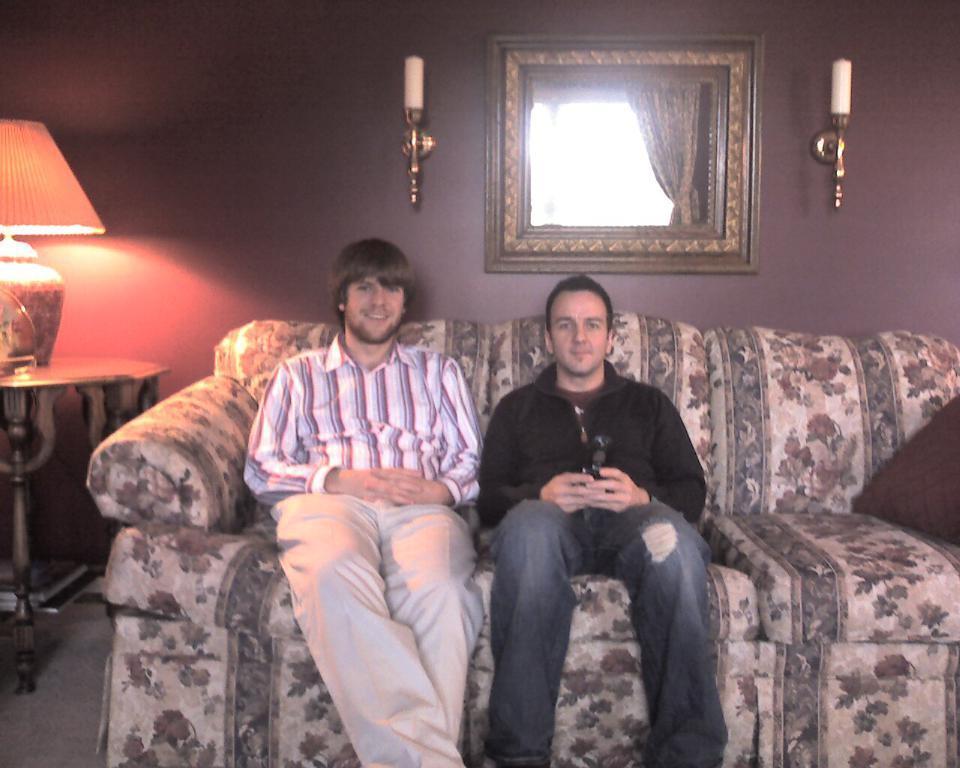How many people are sitting on the sofa in the image? There are two men sitting on the sofa in the image. What can be seen in the background of the image? There is a wall and a light lamp on a table in the background. What is attached to the wall in the image? Candles and other objects are attached to the wall in the image. What type of salt can be seen on the sofa in the image? There is no salt present on the sofa in the image. Can you describe the agreement between the two men sitting on the sofa? The image does not provide any information about an agreement between the two men; it only shows them sitting on the sofa. 